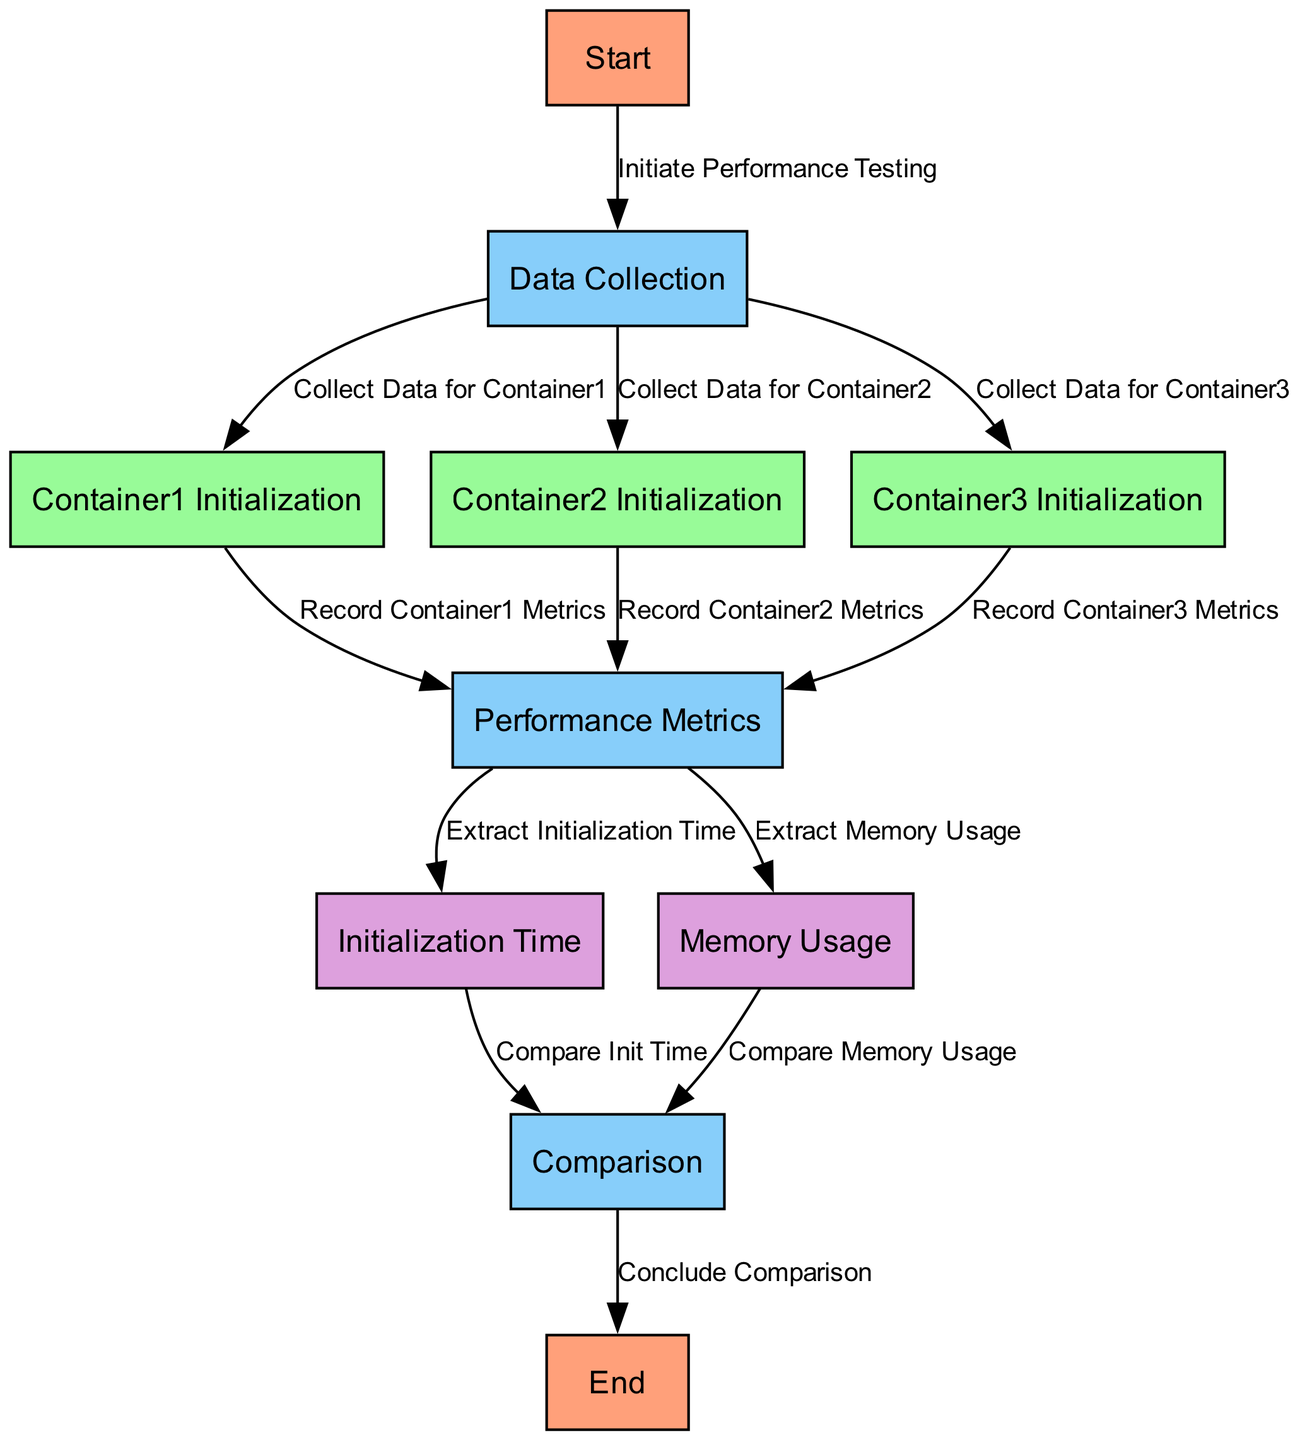What is the first step in the diagram? The diagram begins with the "Start" node, which indicates the initiation of the performance testing process. The flow starts here before proceeding to data collection.
Answer: Start How many containers are initialized in this benchmarking process? The diagram includes three initialization nodes for Container1, Container2, and Container3. Each corresponds to a specific container being tested.
Answer: Three What node follows the "Data Collection" node? After collecting data, the diagram flows to the initialization of Container1, Container2, and Container3, but as a single node, the next specific node is "Container1 Initialization."
Answer: Container1 Initialization What performance metrics are extracted from the “Performance Metrics” node? The diagram shows two metrics being extracted from the performance metrics node, namely "Initialization Time" and "Memory Usage." These are crucial for the comparison phase following their extraction.
Answer: Initialization Time and Memory Usage Which nodes are used to compare the gathered performance data? The comparison is conducted between the nodes representing the "Initialization Time" and "Memory Usage." Both metrics are analyzed together to reach a conclusion at the "Comparison" node.
Answer: Initialization Time and Memory Usage What happens after comparing initialization time and memory usage? Following the comparisons of both metrics, the flow concludes at the "End" node, indicating that the performance benchmarking process has reached its conclusion after evaluating the results.
Answer: End How many edges connect the "Performance Metrics" node to subsequent nodes? There are two edges departing from the "Performance Metrics" node, one for "Extract Initialization Time" and another for "Extract Memory Usage." These represent the direct flow from the metrics to the comparison phase.
Answer: Two What is indicated by the label "Conclude Comparison"? The label "Conclude Comparison" signifies the endpoint of the benchmarking process where the gathered data and metrics from previous nodes are summarized and finalized at the end of the performance evaluation.
Answer: Conclude Comparison 